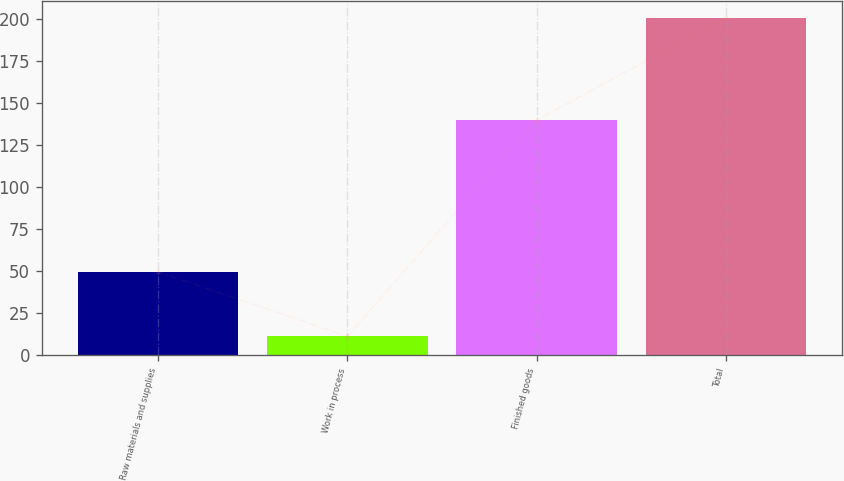<chart> <loc_0><loc_0><loc_500><loc_500><bar_chart><fcel>Raw materials and supplies<fcel>Work in process<fcel>Finished goods<fcel>Total<nl><fcel>49.6<fcel>11.3<fcel>139.8<fcel>200.7<nl></chart> 